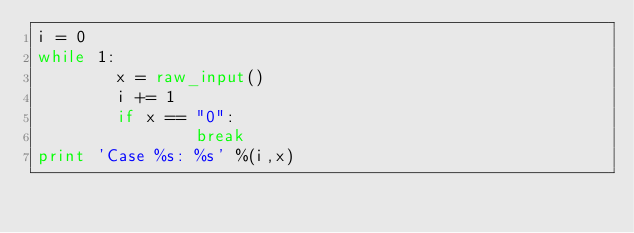Convert code to text. <code><loc_0><loc_0><loc_500><loc_500><_Python_>i = 0
while 1:
        x = raw_input()
        i += 1
        if x == "0":
                break
print 'Case %s: %s' %(i,x)</code> 